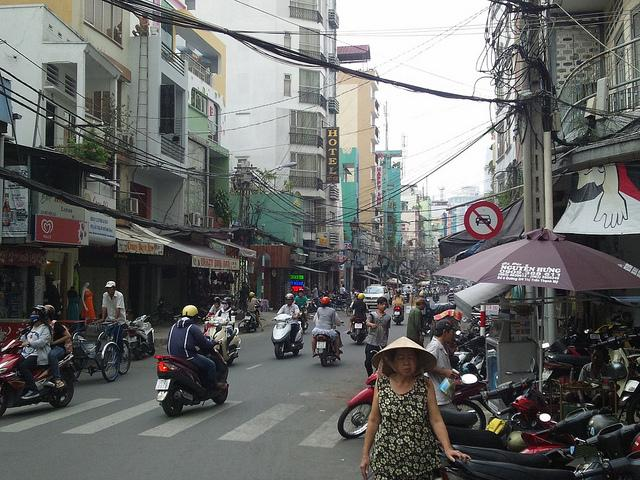Why is the woman wearing a triangular hat? Please explain your reasoning. protection. This keeps the sun off her face 